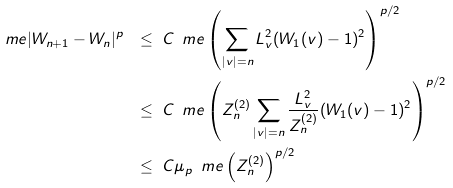Convert formula to latex. <formula><loc_0><loc_0><loc_500><loc_500>\ m e | W _ { n + 1 } - W _ { n } | ^ { p } \ & \leq \ C \, \ m e \left ( \sum _ { | v | = n } L _ { v } ^ { 2 } ( W _ { 1 } ( v ) - 1 ) ^ { 2 } \right ) ^ { p / 2 } \\ & \leq \ C \, \ m e \left ( Z _ { n } ^ { ( 2 ) } \sum _ { | v | = n } \frac { L _ { v } ^ { 2 } } { Z _ { n } ^ { ( 2 ) } } ( W _ { 1 } ( v ) - 1 ) ^ { 2 } \right ) ^ { p / 2 } \\ & \leq \ C \mu _ { p } \, \ m e \left ( Z _ { n } ^ { ( 2 ) } \right ) ^ { p / 2 }</formula> 